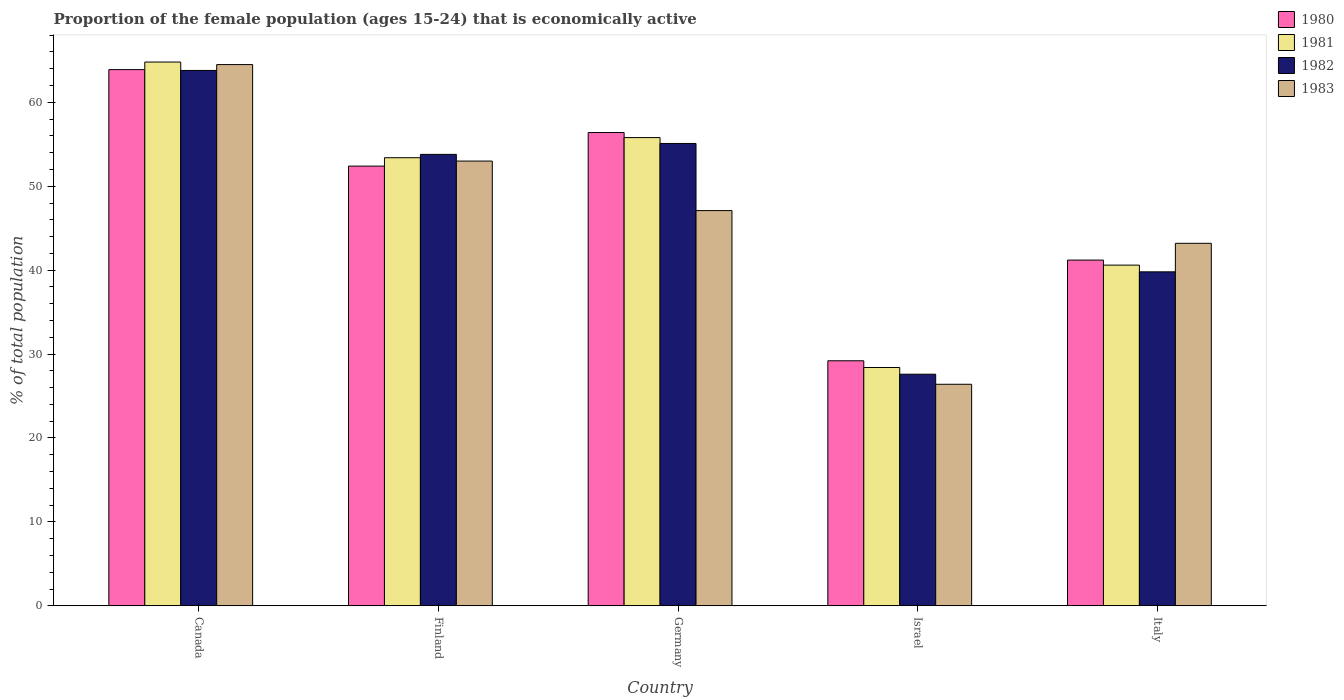How many groups of bars are there?
Provide a short and direct response. 5. What is the label of the 4th group of bars from the left?
Give a very brief answer. Israel. What is the proportion of the female population that is economically active in 1981 in Finland?
Your response must be concise. 53.4. Across all countries, what is the maximum proportion of the female population that is economically active in 1980?
Make the answer very short. 63.9. Across all countries, what is the minimum proportion of the female population that is economically active in 1983?
Offer a terse response. 26.4. In which country was the proportion of the female population that is economically active in 1982 minimum?
Provide a short and direct response. Israel. What is the total proportion of the female population that is economically active in 1983 in the graph?
Your response must be concise. 234.2. What is the difference between the proportion of the female population that is economically active in 1981 in Germany and that in Israel?
Keep it short and to the point. 27.4. What is the difference between the proportion of the female population that is economically active in 1981 in Israel and the proportion of the female population that is economically active in 1983 in Italy?
Give a very brief answer. -14.8. What is the average proportion of the female population that is economically active in 1983 per country?
Make the answer very short. 46.84. What is the difference between the proportion of the female population that is economically active of/in 1983 and proportion of the female population that is economically active of/in 1980 in Finland?
Your answer should be compact. 0.6. In how many countries, is the proportion of the female population that is economically active in 1981 greater than 8 %?
Make the answer very short. 5. What is the ratio of the proportion of the female population that is economically active in 1982 in Canada to that in Finland?
Your response must be concise. 1.19. Is the proportion of the female population that is economically active in 1980 in Canada less than that in Finland?
Provide a short and direct response. No. What is the difference between the highest and the second highest proportion of the female population that is economically active in 1981?
Give a very brief answer. 11.4. What is the difference between the highest and the lowest proportion of the female population that is economically active in 1981?
Offer a very short reply. 36.4. In how many countries, is the proportion of the female population that is economically active in 1980 greater than the average proportion of the female population that is economically active in 1980 taken over all countries?
Ensure brevity in your answer.  3. What does the 3rd bar from the right in Israel represents?
Give a very brief answer. 1981. Is it the case that in every country, the sum of the proportion of the female population that is economically active in 1981 and proportion of the female population that is economically active in 1980 is greater than the proportion of the female population that is economically active in 1982?
Ensure brevity in your answer.  Yes. What is the difference between two consecutive major ticks on the Y-axis?
Keep it short and to the point. 10. Does the graph contain grids?
Make the answer very short. No. How many legend labels are there?
Ensure brevity in your answer.  4. How are the legend labels stacked?
Make the answer very short. Vertical. What is the title of the graph?
Give a very brief answer. Proportion of the female population (ages 15-24) that is economically active. Does "1981" appear as one of the legend labels in the graph?
Give a very brief answer. Yes. What is the label or title of the Y-axis?
Your answer should be compact. % of total population. What is the % of total population of 1980 in Canada?
Provide a short and direct response. 63.9. What is the % of total population in 1981 in Canada?
Your answer should be compact. 64.8. What is the % of total population in 1982 in Canada?
Offer a very short reply. 63.8. What is the % of total population of 1983 in Canada?
Ensure brevity in your answer.  64.5. What is the % of total population in 1980 in Finland?
Ensure brevity in your answer.  52.4. What is the % of total population in 1981 in Finland?
Keep it short and to the point. 53.4. What is the % of total population in 1982 in Finland?
Make the answer very short. 53.8. What is the % of total population in 1983 in Finland?
Provide a short and direct response. 53. What is the % of total population in 1980 in Germany?
Offer a terse response. 56.4. What is the % of total population in 1981 in Germany?
Give a very brief answer. 55.8. What is the % of total population in 1982 in Germany?
Your response must be concise. 55.1. What is the % of total population in 1983 in Germany?
Ensure brevity in your answer.  47.1. What is the % of total population in 1980 in Israel?
Your answer should be compact. 29.2. What is the % of total population of 1981 in Israel?
Offer a very short reply. 28.4. What is the % of total population of 1982 in Israel?
Make the answer very short. 27.6. What is the % of total population in 1983 in Israel?
Give a very brief answer. 26.4. What is the % of total population of 1980 in Italy?
Make the answer very short. 41.2. What is the % of total population of 1981 in Italy?
Keep it short and to the point. 40.6. What is the % of total population in 1982 in Italy?
Offer a very short reply. 39.8. What is the % of total population of 1983 in Italy?
Provide a short and direct response. 43.2. Across all countries, what is the maximum % of total population of 1980?
Provide a short and direct response. 63.9. Across all countries, what is the maximum % of total population of 1981?
Your answer should be very brief. 64.8. Across all countries, what is the maximum % of total population in 1982?
Give a very brief answer. 63.8. Across all countries, what is the maximum % of total population of 1983?
Offer a terse response. 64.5. Across all countries, what is the minimum % of total population in 1980?
Offer a very short reply. 29.2. Across all countries, what is the minimum % of total population in 1981?
Provide a short and direct response. 28.4. Across all countries, what is the minimum % of total population of 1982?
Give a very brief answer. 27.6. Across all countries, what is the minimum % of total population in 1983?
Offer a very short reply. 26.4. What is the total % of total population of 1980 in the graph?
Keep it short and to the point. 243.1. What is the total % of total population in 1981 in the graph?
Your response must be concise. 243. What is the total % of total population of 1982 in the graph?
Make the answer very short. 240.1. What is the total % of total population of 1983 in the graph?
Offer a terse response. 234.2. What is the difference between the % of total population of 1980 in Canada and that in Finland?
Your answer should be very brief. 11.5. What is the difference between the % of total population of 1982 in Canada and that in Finland?
Ensure brevity in your answer.  10. What is the difference between the % of total population in 1982 in Canada and that in Germany?
Offer a very short reply. 8.7. What is the difference between the % of total population in 1980 in Canada and that in Israel?
Your answer should be very brief. 34.7. What is the difference between the % of total population in 1981 in Canada and that in Israel?
Offer a terse response. 36.4. What is the difference between the % of total population of 1982 in Canada and that in Israel?
Give a very brief answer. 36.2. What is the difference between the % of total population of 1983 in Canada and that in Israel?
Offer a terse response. 38.1. What is the difference between the % of total population in 1980 in Canada and that in Italy?
Make the answer very short. 22.7. What is the difference between the % of total population in 1981 in Canada and that in Italy?
Offer a terse response. 24.2. What is the difference between the % of total population of 1983 in Canada and that in Italy?
Provide a short and direct response. 21.3. What is the difference between the % of total population in 1980 in Finland and that in Germany?
Your answer should be compact. -4. What is the difference between the % of total population in 1980 in Finland and that in Israel?
Provide a short and direct response. 23.2. What is the difference between the % of total population of 1982 in Finland and that in Israel?
Ensure brevity in your answer.  26.2. What is the difference between the % of total population of 1983 in Finland and that in Israel?
Your answer should be compact. 26.6. What is the difference between the % of total population of 1981 in Finland and that in Italy?
Offer a terse response. 12.8. What is the difference between the % of total population of 1980 in Germany and that in Israel?
Provide a succinct answer. 27.2. What is the difference between the % of total population of 1981 in Germany and that in Israel?
Give a very brief answer. 27.4. What is the difference between the % of total population of 1983 in Germany and that in Israel?
Provide a succinct answer. 20.7. What is the difference between the % of total population of 1982 in Germany and that in Italy?
Ensure brevity in your answer.  15.3. What is the difference between the % of total population of 1982 in Israel and that in Italy?
Offer a very short reply. -12.2. What is the difference between the % of total population in 1983 in Israel and that in Italy?
Make the answer very short. -16.8. What is the difference between the % of total population in 1980 in Canada and the % of total population in 1982 in Finland?
Your answer should be compact. 10.1. What is the difference between the % of total population of 1981 in Canada and the % of total population of 1982 in Finland?
Your answer should be compact. 11. What is the difference between the % of total population of 1981 in Canada and the % of total population of 1983 in Finland?
Ensure brevity in your answer.  11.8. What is the difference between the % of total population of 1982 in Canada and the % of total population of 1983 in Finland?
Your response must be concise. 10.8. What is the difference between the % of total population of 1980 in Canada and the % of total population of 1982 in Germany?
Make the answer very short. 8.8. What is the difference between the % of total population in 1981 in Canada and the % of total population in 1982 in Germany?
Ensure brevity in your answer.  9.7. What is the difference between the % of total population in 1981 in Canada and the % of total population in 1983 in Germany?
Provide a short and direct response. 17.7. What is the difference between the % of total population of 1982 in Canada and the % of total population of 1983 in Germany?
Your response must be concise. 16.7. What is the difference between the % of total population in 1980 in Canada and the % of total population in 1981 in Israel?
Your answer should be compact. 35.5. What is the difference between the % of total population of 1980 in Canada and the % of total population of 1982 in Israel?
Your response must be concise. 36.3. What is the difference between the % of total population of 1980 in Canada and the % of total population of 1983 in Israel?
Ensure brevity in your answer.  37.5. What is the difference between the % of total population in 1981 in Canada and the % of total population in 1982 in Israel?
Provide a succinct answer. 37.2. What is the difference between the % of total population in 1981 in Canada and the % of total population in 1983 in Israel?
Offer a very short reply. 38.4. What is the difference between the % of total population of 1982 in Canada and the % of total population of 1983 in Israel?
Keep it short and to the point. 37.4. What is the difference between the % of total population of 1980 in Canada and the % of total population of 1981 in Italy?
Ensure brevity in your answer.  23.3. What is the difference between the % of total population in 1980 in Canada and the % of total population in 1982 in Italy?
Ensure brevity in your answer.  24.1. What is the difference between the % of total population in 1980 in Canada and the % of total population in 1983 in Italy?
Your answer should be very brief. 20.7. What is the difference between the % of total population in 1981 in Canada and the % of total population in 1983 in Italy?
Give a very brief answer. 21.6. What is the difference between the % of total population of 1982 in Canada and the % of total population of 1983 in Italy?
Your response must be concise. 20.6. What is the difference between the % of total population of 1980 in Finland and the % of total population of 1982 in Israel?
Your answer should be very brief. 24.8. What is the difference between the % of total population in 1980 in Finland and the % of total population in 1983 in Israel?
Keep it short and to the point. 26. What is the difference between the % of total population in 1981 in Finland and the % of total population in 1982 in Israel?
Provide a succinct answer. 25.8. What is the difference between the % of total population in 1982 in Finland and the % of total population in 1983 in Israel?
Keep it short and to the point. 27.4. What is the difference between the % of total population in 1981 in Finland and the % of total population in 1982 in Italy?
Offer a terse response. 13.6. What is the difference between the % of total population in 1982 in Finland and the % of total population in 1983 in Italy?
Your answer should be very brief. 10.6. What is the difference between the % of total population of 1980 in Germany and the % of total population of 1981 in Israel?
Provide a short and direct response. 28. What is the difference between the % of total population of 1980 in Germany and the % of total population of 1982 in Israel?
Make the answer very short. 28.8. What is the difference between the % of total population in 1981 in Germany and the % of total population in 1982 in Israel?
Offer a very short reply. 28.2. What is the difference between the % of total population in 1981 in Germany and the % of total population in 1983 in Israel?
Ensure brevity in your answer.  29.4. What is the difference between the % of total population of 1982 in Germany and the % of total population of 1983 in Israel?
Ensure brevity in your answer.  28.7. What is the difference between the % of total population in 1982 in Germany and the % of total population in 1983 in Italy?
Offer a terse response. 11.9. What is the difference between the % of total population in 1980 in Israel and the % of total population in 1981 in Italy?
Provide a succinct answer. -11.4. What is the difference between the % of total population in 1980 in Israel and the % of total population in 1982 in Italy?
Make the answer very short. -10.6. What is the difference between the % of total population of 1981 in Israel and the % of total population of 1983 in Italy?
Give a very brief answer. -14.8. What is the difference between the % of total population in 1982 in Israel and the % of total population in 1983 in Italy?
Keep it short and to the point. -15.6. What is the average % of total population of 1980 per country?
Ensure brevity in your answer.  48.62. What is the average % of total population in 1981 per country?
Offer a terse response. 48.6. What is the average % of total population in 1982 per country?
Keep it short and to the point. 48.02. What is the average % of total population of 1983 per country?
Offer a very short reply. 46.84. What is the difference between the % of total population of 1980 and % of total population of 1981 in Canada?
Your response must be concise. -0.9. What is the difference between the % of total population in 1980 and % of total population in 1983 in Canada?
Keep it short and to the point. -0.6. What is the difference between the % of total population in 1980 and % of total population in 1981 in Finland?
Make the answer very short. -1. What is the difference between the % of total population in 1980 and % of total population in 1982 in Finland?
Ensure brevity in your answer.  -1.4. What is the difference between the % of total population of 1980 and % of total population of 1983 in Finland?
Your answer should be compact. -0.6. What is the difference between the % of total population of 1981 and % of total population of 1983 in Finland?
Give a very brief answer. 0.4. What is the difference between the % of total population of 1982 and % of total population of 1983 in Finland?
Offer a terse response. 0.8. What is the difference between the % of total population in 1980 and % of total population in 1981 in Germany?
Your answer should be compact. 0.6. What is the difference between the % of total population in 1981 and % of total population in 1982 in Germany?
Your answer should be compact. 0.7. What is the difference between the % of total population of 1980 and % of total population of 1981 in Israel?
Provide a short and direct response. 0.8. What is the difference between the % of total population in 1981 and % of total population in 1982 in Israel?
Your answer should be very brief. 0.8. What is the difference between the % of total population of 1981 and % of total population of 1983 in Israel?
Provide a succinct answer. 2. What is the difference between the % of total population of 1982 and % of total population of 1983 in Israel?
Offer a very short reply. 1.2. What is the difference between the % of total population in 1980 and % of total population in 1982 in Italy?
Provide a short and direct response. 1.4. What is the ratio of the % of total population in 1980 in Canada to that in Finland?
Your response must be concise. 1.22. What is the ratio of the % of total population in 1981 in Canada to that in Finland?
Keep it short and to the point. 1.21. What is the ratio of the % of total population of 1982 in Canada to that in Finland?
Your response must be concise. 1.19. What is the ratio of the % of total population of 1983 in Canada to that in Finland?
Offer a very short reply. 1.22. What is the ratio of the % of total population in 1980 in Canada to that in Germany?
Offer a terse response. 1.13. What is the ratio of the % of total population in 1981 in Canada to that in Germany?
Make the answer very short. 1.16. What is the ratio of the % of total population in 1982 in Canada to that in Germany?
Offer a terse response. 1.16. What is the ratio of the % of total population of 1983 in Canada to that in Germany?
Your answer should be compact. 1.37. What is the ratio of the % of total population in 1980 in Canada to that in Israel?
Keep it short and to the point. 2.19. What is the ratio of the % of total population in 1981 in Canada to that in Israel?
Provide a succinct answer. 2.28. What is the ratio of the % of total population in 1982 in Canada to that in Israel?
Give a very brief answer. 2.31. What is the ratio of the % of total population of 1983 in Canada to that in Israel?
Ensure brevity in your answer.  2.44. What is the ratio of the % of total population in 1980 in Canada to that in Italy?
Make the answer very short. 1.55. What is the ratio of the % of total population of 1981 in Canada to that in Italy?
Offer a terse response. 1.6. What is the ratio of the % of total population of 1982 in Canada to that in Italy?
Provide a short and direct response. 1.6. What is the ratio of the % of total population in 1983 in Canada to that in Italy?
Offer a very short reply. 1.49. What is the ratio of the % of total population in 1980 in Finland to that in Germany?
Your answer should be very brief. 0.93. What is the ratio of the % of total population of 1982 in Finland to that in Germany?
Your answer should be very brief. 0.98. What is the ratio of the % of total population of 1983 in Finland to that in Germany?
Your answer should be very brief. 1.13. What is the ratio of the % of total population of 1980 in Finland to that in Israel?
Your answer should be compact. 1.79. What is the ratio of the % of total population of 1981 in Finland to that in Israel?
Provide a short and direct response. 1.88. What is the ratio of the % of total population in 1982 in Finland to that in Israel?
Your response must be concise. 1.95. What is the ratio of the % of total population of 1983 in Finland to that in Israel?
Your answer should be very brief. 2.01. What is the ratio of the % of total population in 1980 in Finland to that in Italy?
Make the answer very short. 1.27. What is the ratio of the % of total population in 1981 in Finland to that in Italy?
Your response must be concise. 1.32. What is the ratio of the % of total population in 1982 in Finland to that in Italy?
Your answer should be very brief. 1.35. What is the ratio of the % of total population of 1983 in Finland to that in Italy?
Ensure brevity in your answer.  1.23. What is the ratio of the % of total population of 1980 in Germany to that in Israel?
Your answer should be very brief. 1.93. What is the ratio of the % of total population in 1981 in Germany to that in Israel?
Provide a succinct answer. 1.96. What is the ratio of the % of total population in 1982 in Germany to that in Israel?
Offer a very short reply. 2. What is the ratio of the % of total population of 1983 in Germany to that in Israel?
Provide a short and direct response. 1.78. What is the ratio of the % of total population in 1980 in Germany to that in Italy?
Provide a succinct answer. 1.37. What is the ratio of the % of total population in 1981 in Germany to that in Italy?
Provide a short and direct response. 1.37. What is the ratio of the % of total population in 1982 in Germany to that in Italy?
Offer a very short reply. 1.38. What is the ratio of the % of total population in 1983 in Germany to that in Italy?
Keep it short and to the point. 1.09. What is the ratio of the % of total population of 1980 in Israel to that in Italy?
Provide a succinct answer. 0.71. What is the ratio of the % of total population in 1981 in Israel to that in Italy?
Your answer should be compact. 0.7. What is the ratio of the % of total population of 1982 in Israel to that in Italy?
Provide a short and direct response. 0.69. What is the ratio of the % of total population of 1983 in Israel to that in Italy?
Your answer should be very brief. 0.61. What is the difference between the highest and the second highest % of total population of 1981?
Offer a very short reply. 9. What is the difference between the highest and the second highest % of total population in 1982?
Keep it short and to the point. 8.7. What is the difference between the highest and the lowest % of total population of 1980?
Give a very brief answer. 34.7. What is the difference between the highest and the lowest % of total population of 1981?
Provide a short and direct response. 36.4. What is the difference between the highest and the lowest % of total population of 1982?
Offer a terse response. 36.2. What is the difference between the highest and the lowest % of total population of 1983?
Offer a terse response. 38.1. 